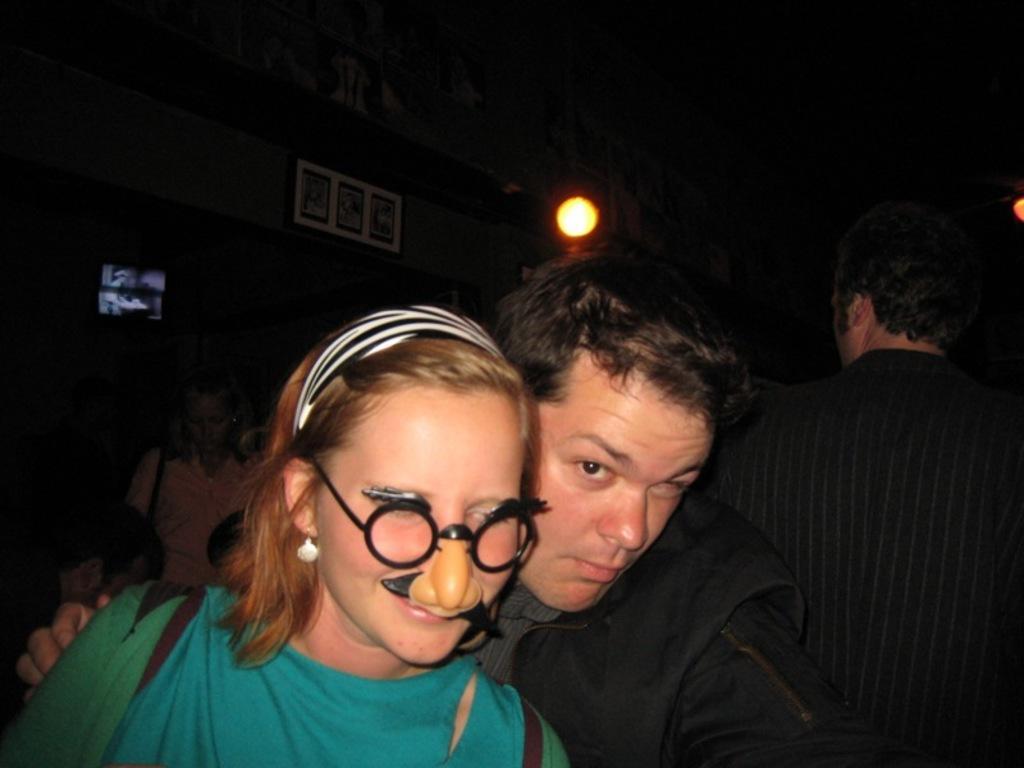How would you summarize this image in a sentence or two? There is a woman in green color t-shirt, standing near a person who is in black color t-shirt. In the background, there is a person in black color dress, there is a light, a screen and photo frames on the wall. And the background is dark in color. 